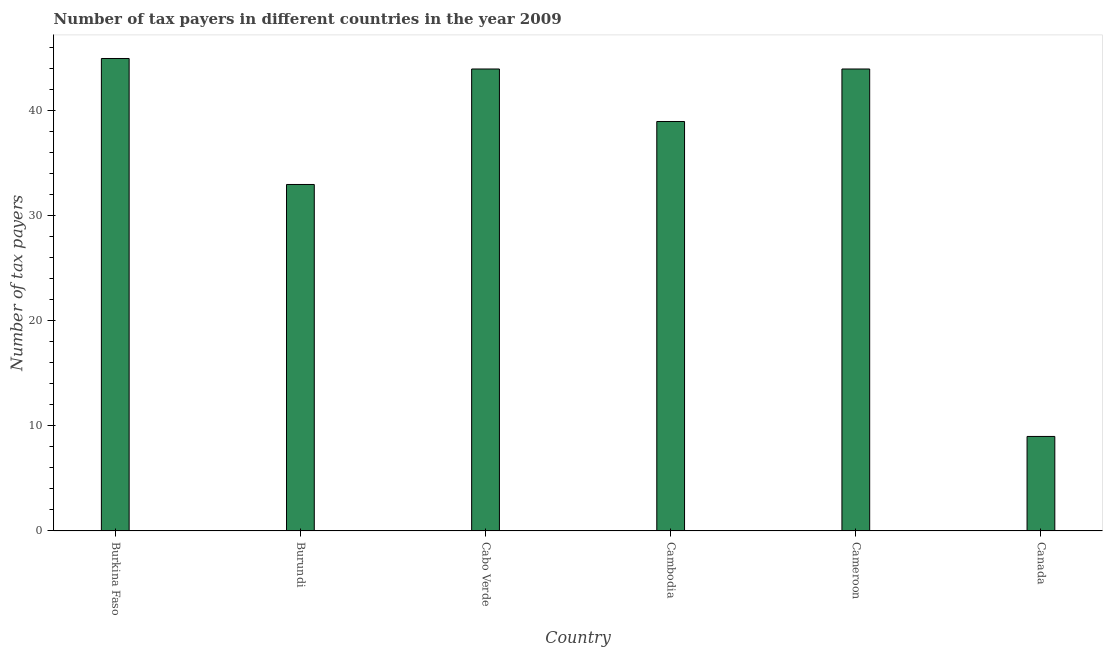Does the graph contain any zero values?
Provide a succinct answer. No. What is the title of the graph?
Your response must be concise. Number of tax payers in different countries in the year 2009. What is the label or title of the Y-axis?
Your answer should be very brief. Number of tax payers. What is the number of tax payers in Burkina Faso?
Your answer should be compact. 45. Across all countries, what is the maximum number of tax payers?
Offer a terse response. 45. Across all countries, what is the minimum number of tax payers?
Make the answer very short. 9. In which country was the number of tax payers maximum?
Make the answer very short. Burkina Faso. What is the sum of the number of tax payers?
Your answer should be very brief. 214. What is the difference between the number of tax payers in Burundi and Cabo Verde?
Give a very brief answer. -11. What is the average number of tax payers per country?
Offer a very short reply. 35.67. What is the median number of tax payers?
Your response must be concise. 41.5. In how many countries, is the number of tax payers greater than 6 ?
Provide a short and direct response. 6. What is the ratio of the number of tax payers in Cabo Verde to that in Cambodia?
Keep it short and to the point. 1.13. What is the difference between the highest and the second highest number of tax payers?
Your answer should be compact. 1. What is the difference between the highest and the lowest number of tax payers?
Offer a terse response. 36. In how many countries, is the number of tax payers greater than the average number of tax payers taken over all countries?
Your response must be concise. 4. How many bars are there?
Keep it short and to the point. 6. How many countries are there in the graph?
Your response must be concise. 6. What is the difference between two consecutive major ticks on the Y-axis?
Your answer should be compact. 10. What is the Number of tax payers of Burkina Faso?
Keep it short and to the point. 45. What is the Number of tax payers in Burundi?
Offer a very short reply. 33. What is the difference between the Number of tax payers in Burkina Faso and Cambodia?
Provide a succinct answer. 6. What is the difference between the Number of tax payers in Burkina Faso and Canada?
Keep it short and to the point. 36. What is the difference between the Number of tax payers in Burundi and Canada?
Offer a terse response. 24. What is the difference between the Number of tax payers in Cabo Verde and Cambodia?
Make the answer very short. 5. What is the difference between the Number of tax payers in Cabo Verde and Cameroon?
Offer a terse response. 0. What is the difference between the Number of tax payers in Cabo Verde and Canada?
Your response must be concise. 35. What is the difference between the Number of tax payers in Cambodia and Cameroon?
Make the answer very short. -5. What is the difference between the Number of tax payers in Cambodia and Canada?
Keep it short and to the point. 30. What is the ratio of the Number of tax payers in Burkina Faso to that in Burundi?
Your answer should be very brief. 1.36. What is the ratio of the Number of tax payers in Burkina Faso to that in Cambodia?
Your answer should be compact. 1.15. What is the ratio of the Number of tax payers in Burundi to that in Cabo Verde?
Offer a very short reply. 0.75. What is the ratio of the Number of tax payers in Burundi to that in Cambodia?
Your answer should be compact. 0.85. What is the ratio of the Number of tax payers in Burundi to that in Cameroon?
Your answer should be very brief. 0.75. What is the ratio of the Number of tax payers in Burundi to that in Canada?
Ensure brevity in your answer.  3.67. What is the ratio of the Number of tax payers in Cabo Verde to that in Cambodia?
Make the answer very short. 1.13. What is the ratio of the Number of tax payers in Cabo Verde to that in Cameroon?
Ensure brevity in your answer.  1. What is the ratio of the Number of tax payers in Cabo Verde to that in Canada?
Your answer should be compact. 4.89. What is the ratio of the Number of tax payers in Cambodia to that in Cameroon?
Make the answer very short. 0.89. What is the ratio of the Number of tax payers in Cambodia to that in Canada?
Offer a very short reply. 4.33. What is the ratio of the Number of tax payers in Cameroon to that in Canada?
Provide a short and direct response. 4.89. 